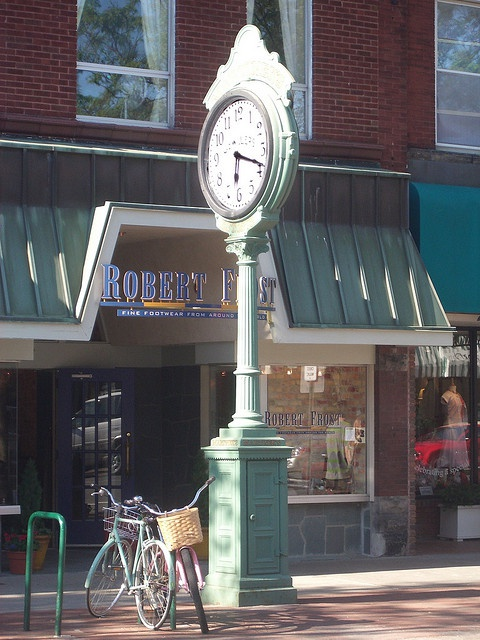Describe the objects in this image and their specific colors. I can see bicycle in maroon, gray, darkgray, white, and black tones, clock in maroon, white, darkgray, and gray tones, and bicycle in maroon, gray, ivory, and tan tones in this image. 